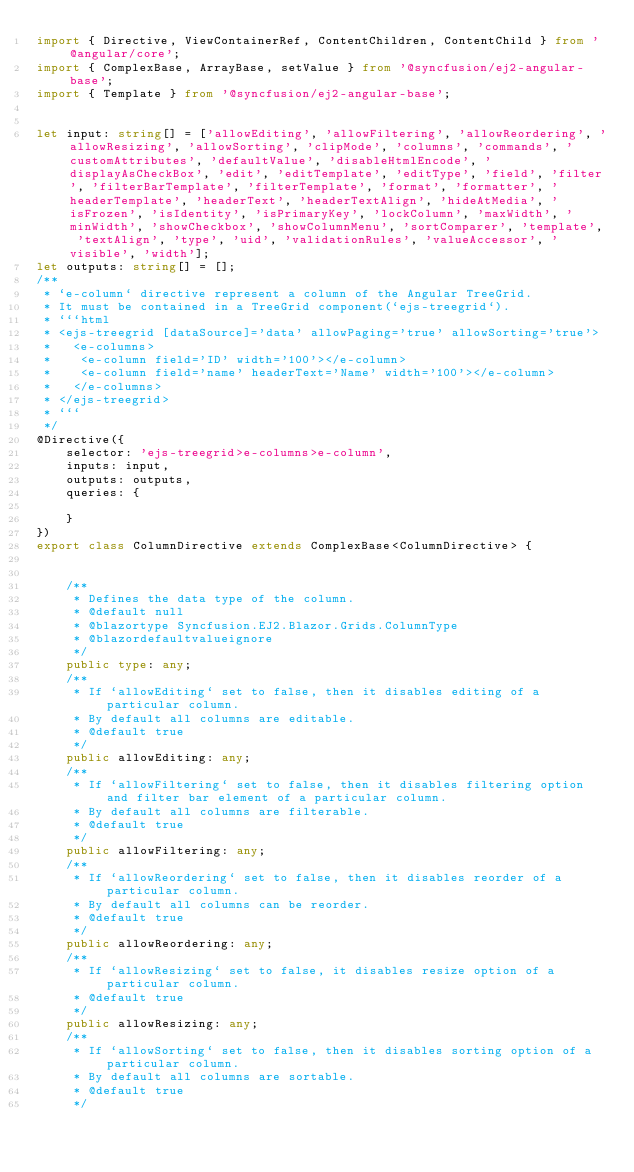Convert code to text. <code><loc_0><loc_0><loc_500><loc_500><_TypeScript_>import { Directive, ViewContainerRef, ContentChildren, ContentChild } from '@angular/core';
import { ComplexBase, ArrayBase, setValue } from '@syncfusion/ej2-angular-base';
import { Template } from '@syncfusion/ej2-angular-base';


let input: string[] = ['allowEditing', 'allowFiltering', 'allowReordering', 'allowResizing', 'allowSorting', 'clipMode', 'columns', 'commands', 'customAttributes', 'defaultValue', 'disableHtmlEncode', 'displayAsCheckBox', 'edit', 'editTemplate', 'editType', 'field', 'filter', 'filterBarTemplate', 'filterTemplate', 'format', 'formatter', 'headerTemplate', 'headerText', 'headerTextAlign', 'hideAtMedia', 'isFrozen', 'isIdentity', 'isPrimaryKey', 'lockColumn', 'maxWidth', 'minWidth', 'showCheckbox', 'showColumnMenu', 'sortComparer', 'template', 'textAlign', 'type', 'uid', 'validationRules', 'valueAccessor', 'visible', 'width'];
let outputs: string[] = [];
/**
 * `e-column` directive represent a column of the Angular TreeGrid. 
 * It must be contained in a TreeGrid component(`ejs-treegrid`). 
 * ```html
 * <ejs-treegrid [dataSource]='data' allowPaging='true' allowSorting='true'> 
 *   <e-columns>
 *    <e-column field='ID' width='100'></e-column>
 *    <e-column field='name' headerText='Name' width='100'></e-column>
 *   </e-columns>
 * </ejs-treegrid>
 * ```
 */
@Directive({
    selector: 'ejs-treegrid>e-columns>e-column',
    inputs: input,
    outputs: outputs,    
    queries: {

    }
})
export class ColumnDirective extends ComplexBase<ColumnDirective> {


    /** 
     * Defines the data type of the column.
     * @default null
     * @blazortype Syncfusion.EJ2.Blazor.Grids.ColumnType
     * @blazordefaultvalueignore 
     */
    public type: any;
    /** 
     * If `allowEditing` set to false, then it disables editing of a particular column. 
     * By default all columns are editable.
     * @default true
     */
    public allowEditing: any;
    /** 
     * If `allowFiltering` set to false, then it disables filtering option and filter bar element of a particular column. 
     * By default all columns are filterable.
     * @default true
     */
    public allowFiltering: any;
    /** 
     * If `allowReordering` set to false, then it disables reorder of a particular column. 
     * By default all columns can be reorder.
     * @default true
     */
    public allowReordering: any;
    /** 
     * If `allowResizing` set to false, it disables resize option of a particular column.
     * @default true
     */
    public allowResizing: any;
    /** 
     * If `allowSorting` set to false, then it disables sorting option of a particular column. 
     * By default all columns are sortable.
     * @default true
     */</code> 